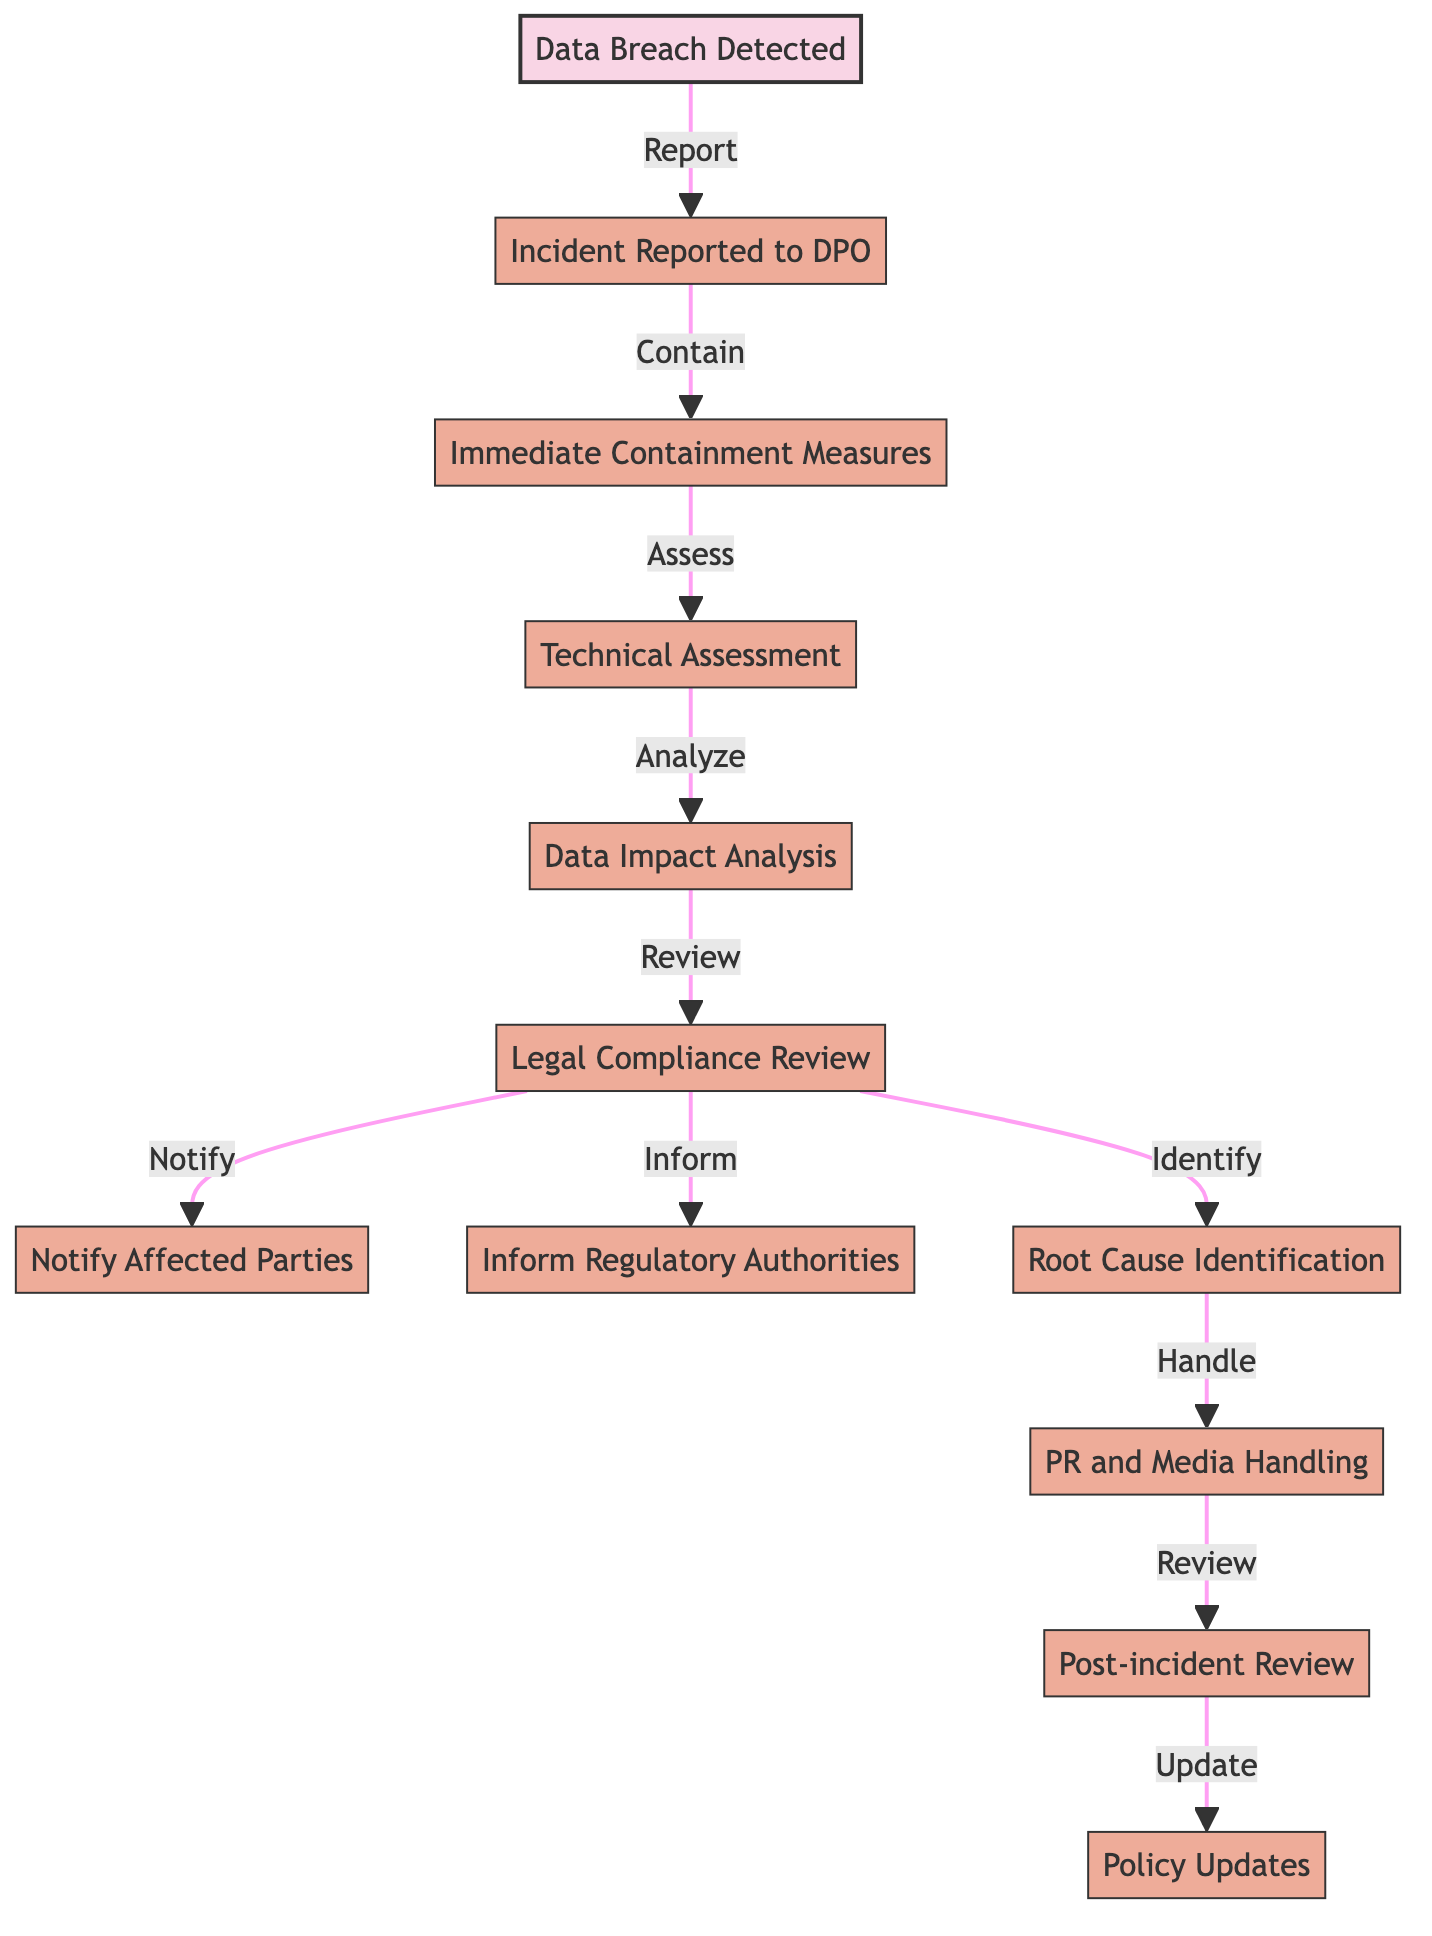What is the starting event in the workflow? The first node in the diagram represents the starting event, which is "Data Breach Detected." This node initiates the entire incident response workflow depicted in the diagram.
Answer: Data Breach Detected How many action nodes are present in the diagram? By counting the nodes classified as actions, we note that there are 11 action nodes in total, indicating various steps taken in response to a data breach.
Answer: 11 What is the final action in the workflow? The last node in the directed path is "Policy and Procedure Updates," which concludes the incident response process after all necessary steps have been taken.
Answer: Policy and Procedure Updates Which node follows the Legal Compliance Review? By looking at the edges connected to the "Legal Compliance Review" node, we see it leads to three different nodes: "Notify Affected Parties," "Inform Regulatory Authorities," and "Root Cause Identification." Therefore, these nodes are the subsequent steps in the workflow.
Answer: Notify Affected Parties, Inform Regulatory Authorities, Root Cause Identification What is the relationship between the "Root Cause Identification" and "Public Relations and Media Handling" nodes? The "Root Cause Identification" node feeds into the "Public Relations and Media Handling" node, indicating that once the root cause is identified, the next step involves managing public relations related to the incident.
Answer: Handle What action initiates the Technical Assessment and Analysis? The edge from the "Immediate Containment Measures Initiated" node points to the "Technical Assessment and Analysis" node. This signifies that once containment measures are in place, a technical assessment is carried out.
Answer: Immediate Containment Measures Initiated How many edges are connected to the "Legal Compliance Review" node? The "Legal Compliance Review" node has three edges emanating from it, leading to three different actions that occur subsequently in the workflow.
Answer: 3 What leads to the Post-incident Review and Reporting? The "Public Relations and Media Handling" node directly connects to the "Post-incident Review and Reporting" node, indicating that after handling PR, a review of the incident is conducted.
Answer: Public Relations and Media Handling 